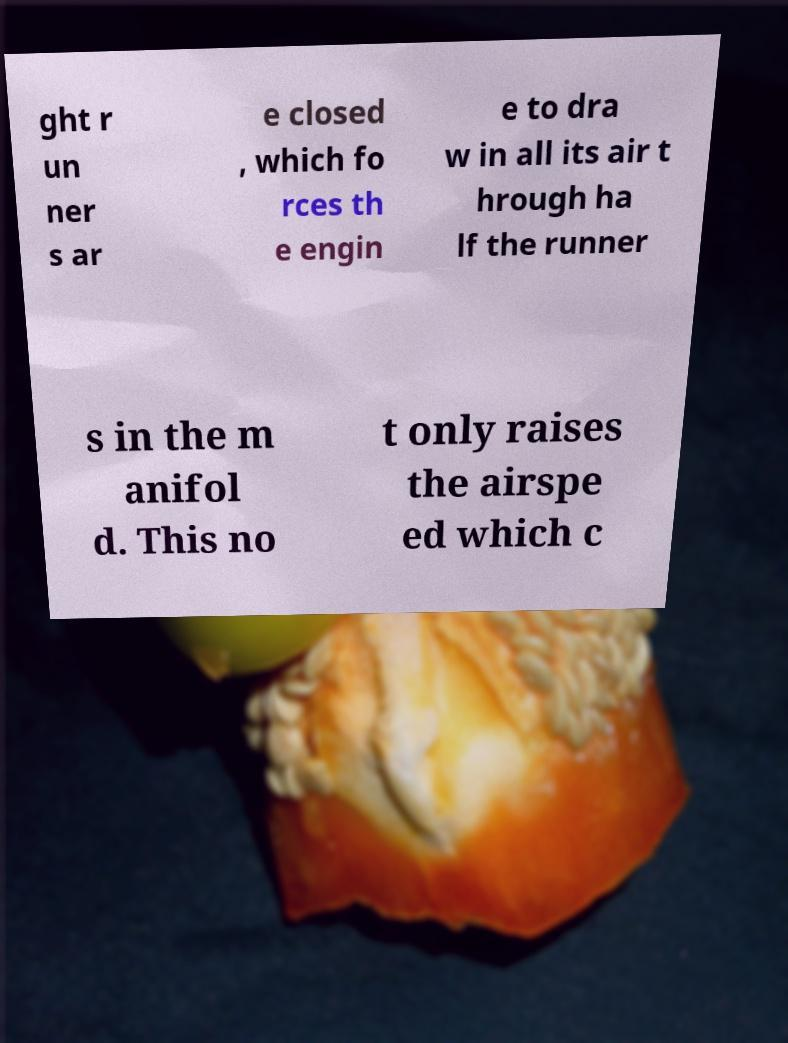Could you extract and type out the text from this image? ght r un ner s ar e closed , which fo rces th e engin e to dra w in all its air t hrough ha lf the runner s in the m anifol d. This no t only raises the airspe ed which c 